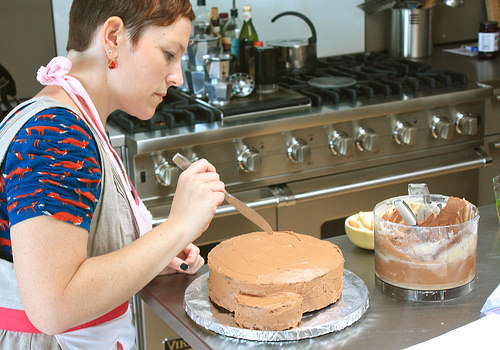<image>
Is there a frosting on the cake? No. The frosting is not positioned on the cake. They may be near each other, but the frosting is not supported by or resting on top of the cake. 